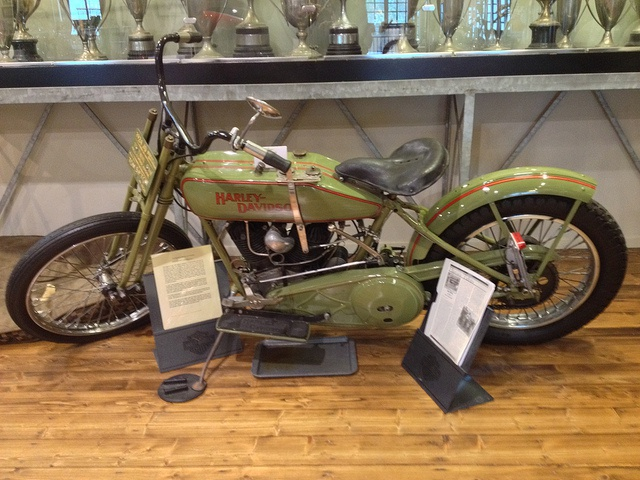Describe the objects in this image and their specific colors. I can see motorcycle in olive, black, gray, and tan tones and book in olive, lightgray, darkgray, and black tones in this image. 